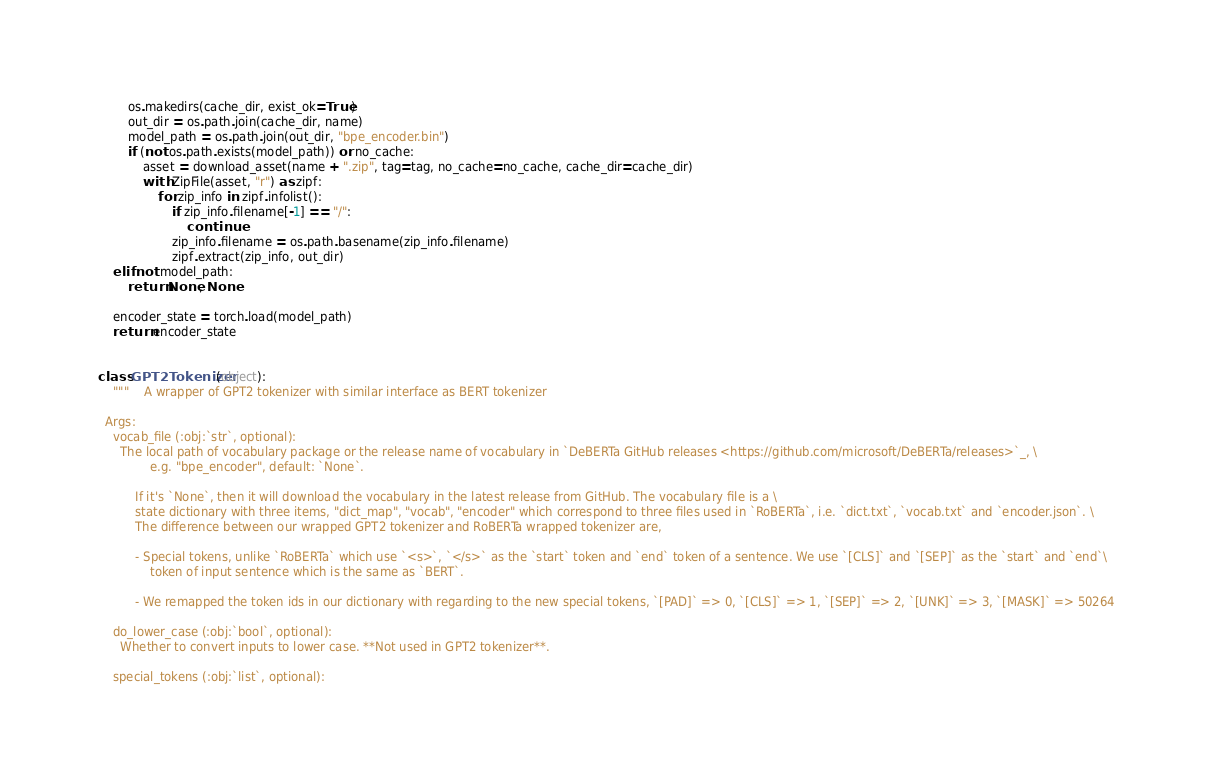<code> <loc_0><loc_0><loc_500><loc_500><_Python_>        os.makedirs(cache_dir, exist_ok=True)
        out_dir = os.path.join(cache_dir, name)
        model_path = os.path.join(out_dir, "bpe_encoder.bin")
        if (not os.path.exists(model_path)) or no_cache:
            asset = download_asset(name + ".zip", tag=tag, no_cache=no_cache, cache_dir=cache_dir)
            with ZipFile(asset, "r") as zipf:
                for zip_info in zipf.infolist():
                    if zip_info.filename[-1] == "/":
                        continue
                    zip_info.filename = os.path.basename(zip_info.filename)
                    zipf.extract(zip_info, out_dir)
    elif not model_path:
        return None, None

    encoder_state = torch.load(model_path)
    return encoder_state


class GPT2Tokenizer(object):
    """    A wrapper of GPT2 tokenizer with similar interface as BERT tokenizer

  Args:
    vocab_file (:obj:`str`, optional):
      The local path of vocabulary package or the release name of vocabulary in `DeBERTa GitHub releases <https://github.com/microsoft/DeBERTa/releases>`_, \
              e.g. "bpe_encoder", default: `None`.

          If it's `None`, then it will download the vocabulary in the latest release from GitHub. The vocabulary file is a \
          state dictionary with three items, "dict_map", "vocab", "encoder" which correspond to three files used in `RoBERTa`, i.e. `dict.txt`, `vocab.txt` and `encoder.json`. \
          The difference between our wrapped GPT2 tokenizer and RoBERTa wrapped tokenizer are,

          - Special tokens, unlike `RoBERTa` which use `<s>`, `</s>` as the `start` token and `end` token of a sentence. We use `[CLS]` and `[SEP]` as the `start` and `end`\
              token of input sentence which is the same as `BERT`.

          - We remapped the token ids in our dictionary with regarding to the new special tokens, `[PAD]` => 0, `[CLS]` => 1, `[SEP]` => 2, `[UNK]` => 3, `[MASK]` => 50264

    do_lower_case (:obj:`bool`, optional):
      Whether to convert inputs to lower case. **Not used in GPT2 tokenizer**.

    special_tokens (:obj:`list`, optional):</code> 